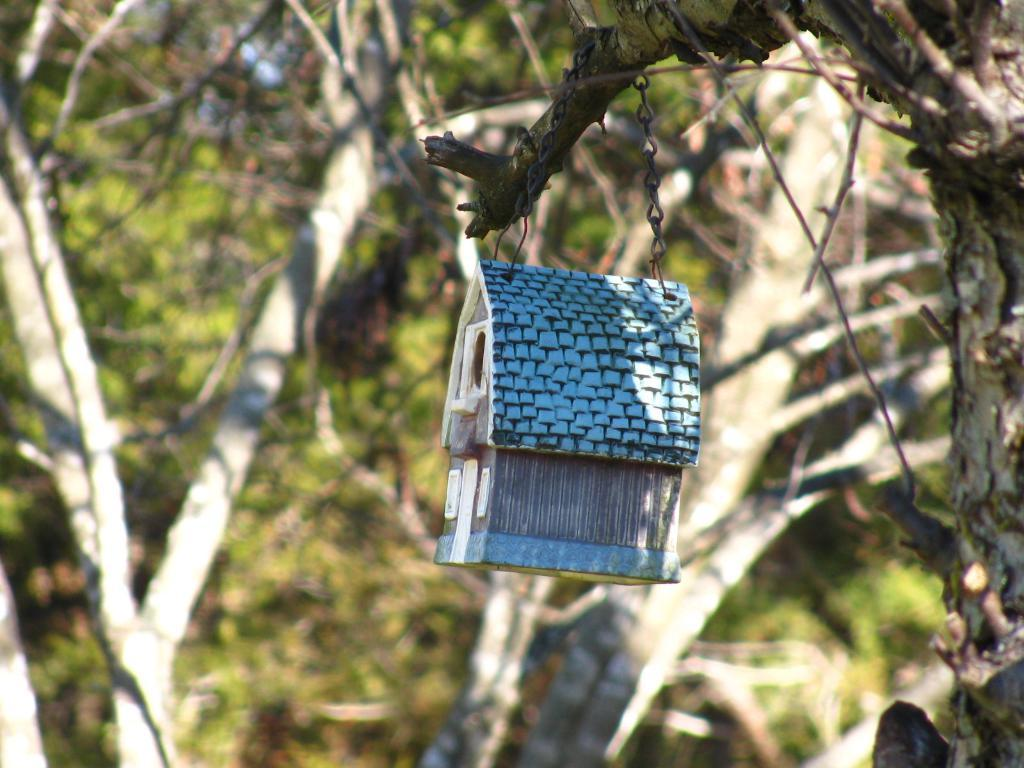What type of structure is visible in the image? There is a house in the image. How is the house positioned in the image? The house is hanging from a branch. What color is the house? The house is blue in color. What can be seen in the background of the image? There are trees in the background of the image. What color are the trees? The trees are green in color. How many sisters are standing next to the house in the image? There are no sisters present in the image; the house is hanging from a branch. 